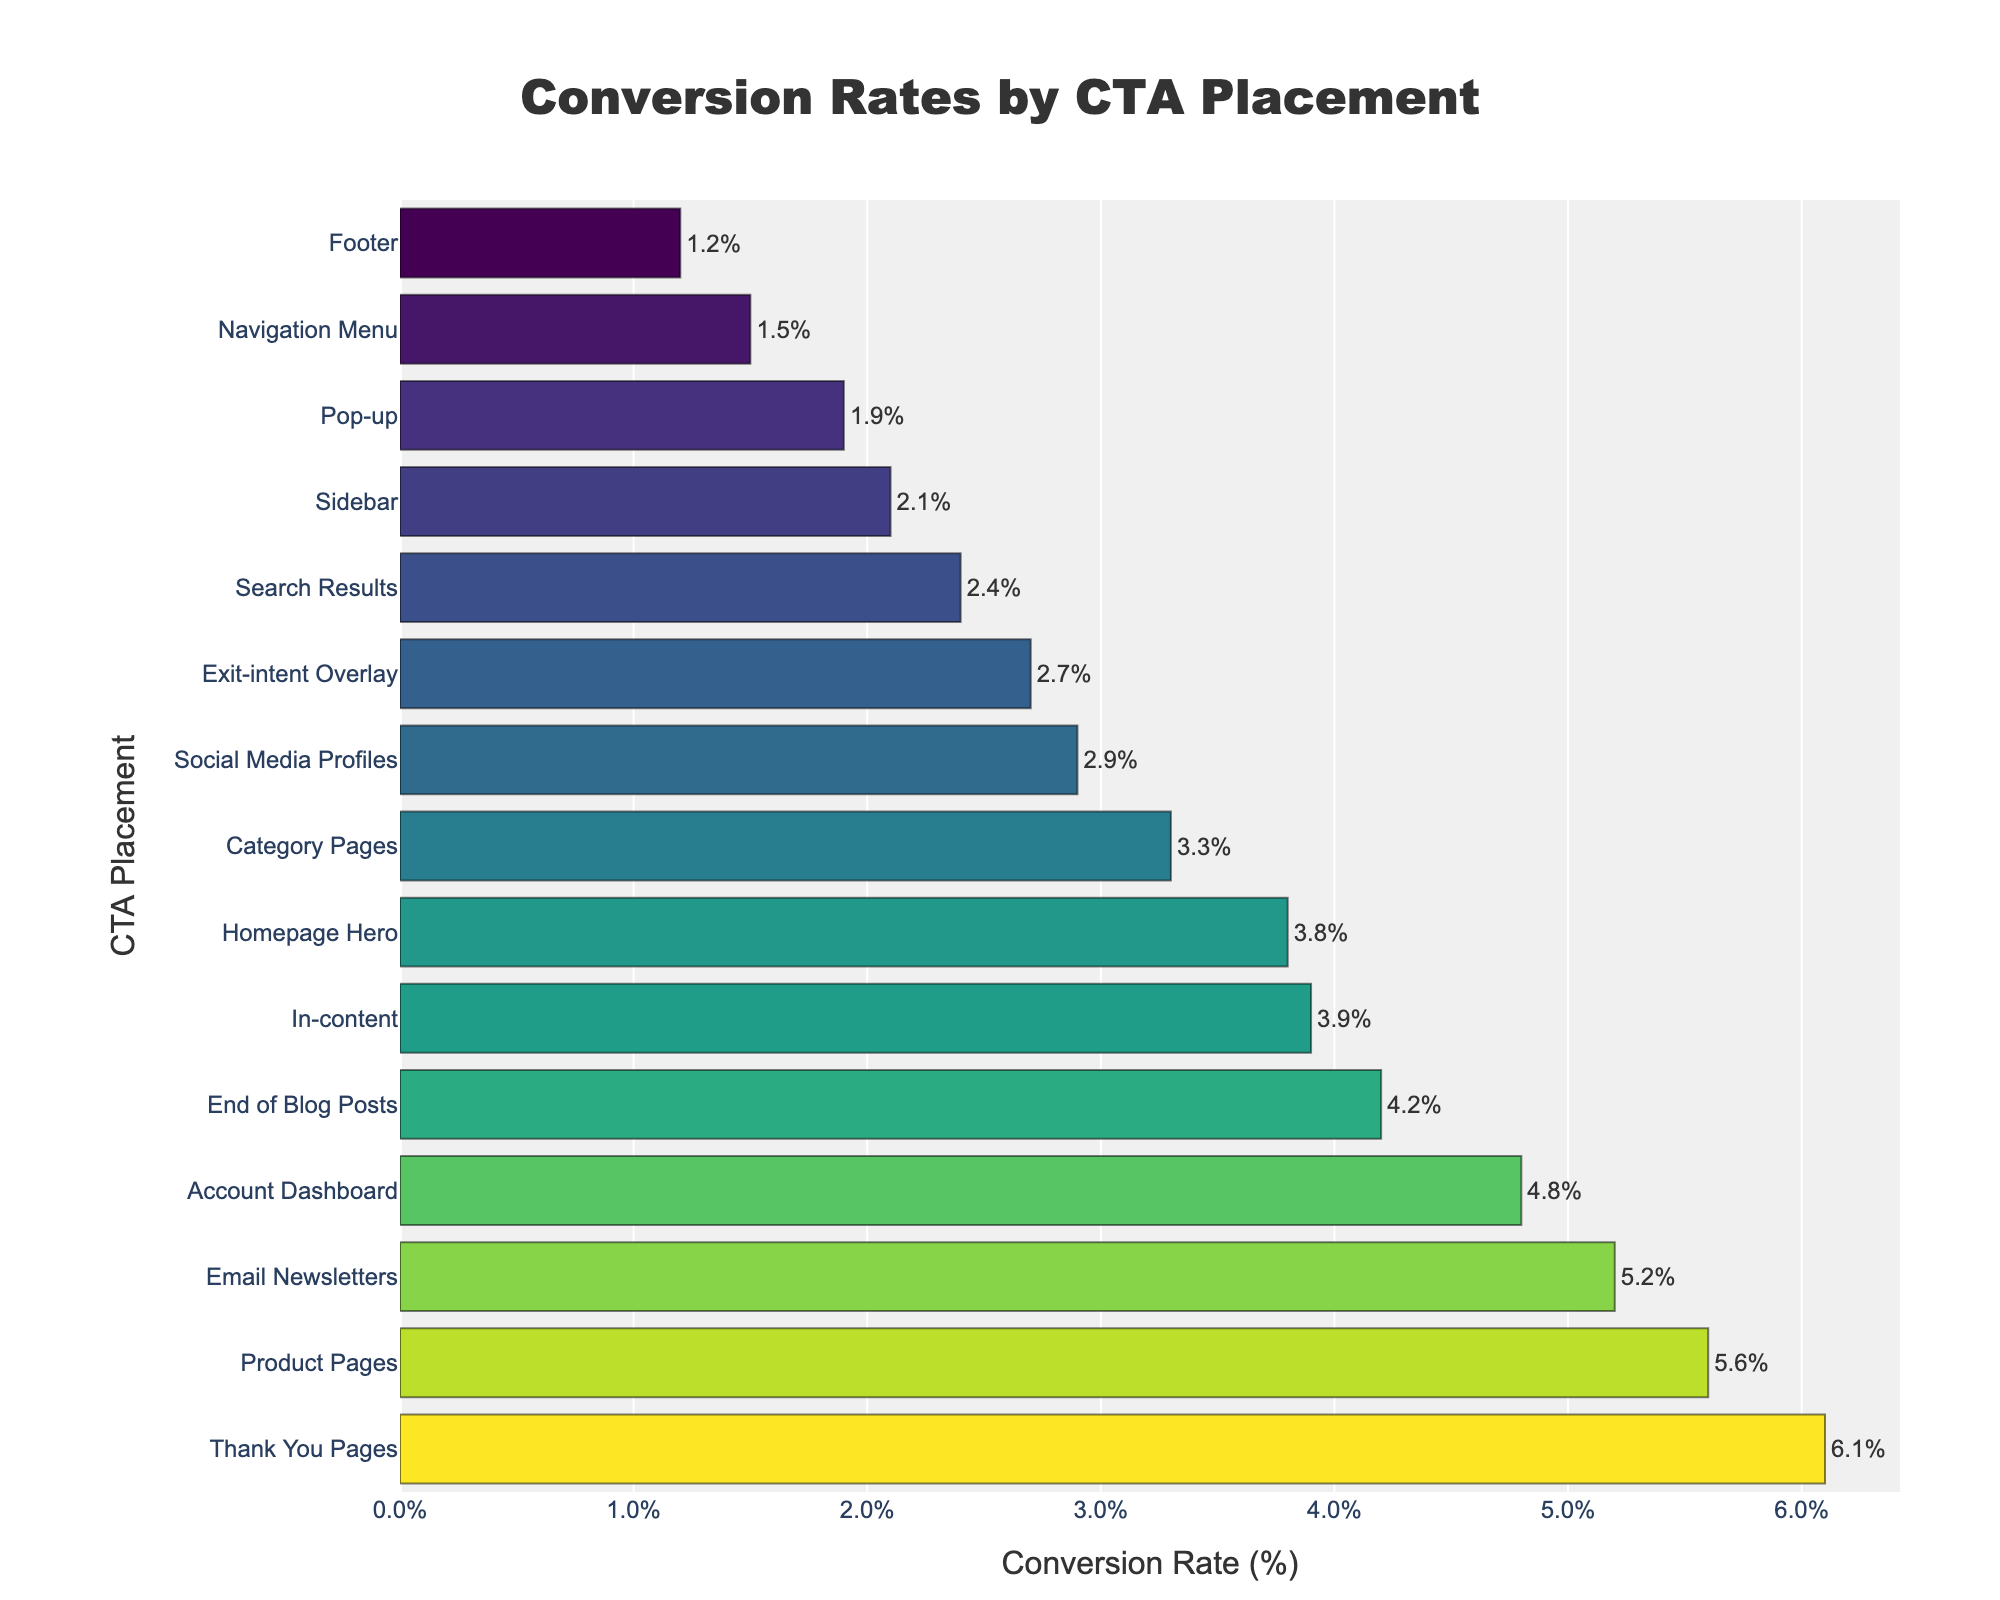what is the highest conversion rate, and which CTA placement achieves it? The highest bar represents the CTA Placement with the highest conversion rate. Looking at the top bar, the Thank You Pages placement achieves the highest conversion rate.
Answer: Thank You Pages, 6.1% Which CTA placement has a conversion rate greater than 5%? To find CTA placements with a conversion rate higher than 5%, look for bars with a value greater than 5%. The CTA placements are Product Pages, Email Newsletters, and Thank You Pages.
Answer: Product Pages, Email Newsletters, Thank You Pages What is the combined conversion rate of Sidebar and Footer placements? Find the conversion rates for Sidebar and Footer, which are 2.1% and 1.2%, respectively. Sum them up: 2.1 + 1.2 = 3.3%.
Answer: 3.3% How does the conversion rate of Homepage Hero compare to that of Social Media Profiles? Find both values: Homepage Hero is 3.8% and Social Media Profiles is 2.9%. The Homepage Hero has a higher conversion rate.
Answer: Homepage Hero is higher What is the total conversion rate for all CTA placements? Sum all the conversion rates in the dataset: 3.8 + 2.1 + 4.2 + 1.9 + 1.2 + 5.6 + 3.3 + 1.5 + 3.9 + 2.7 + 6.1 + 2.4 + 4.8 + 5.2 + 2.9 = 51.6%.
Answer: 51.6% How many CTA placements have a conversion rate lower than 3%? Count the bars with a conversion rate less than 3%. The placements are Pop-up, Footer, Navigation Menu, and Search Results. There are 4 of them.
Answer: 4 Which CTA placement has the shortest bar? The shortest bar represents the lowest conversion rate. The Footer is the shortest bar, reflecting the lowest conversion rate.
Answer: Footer 